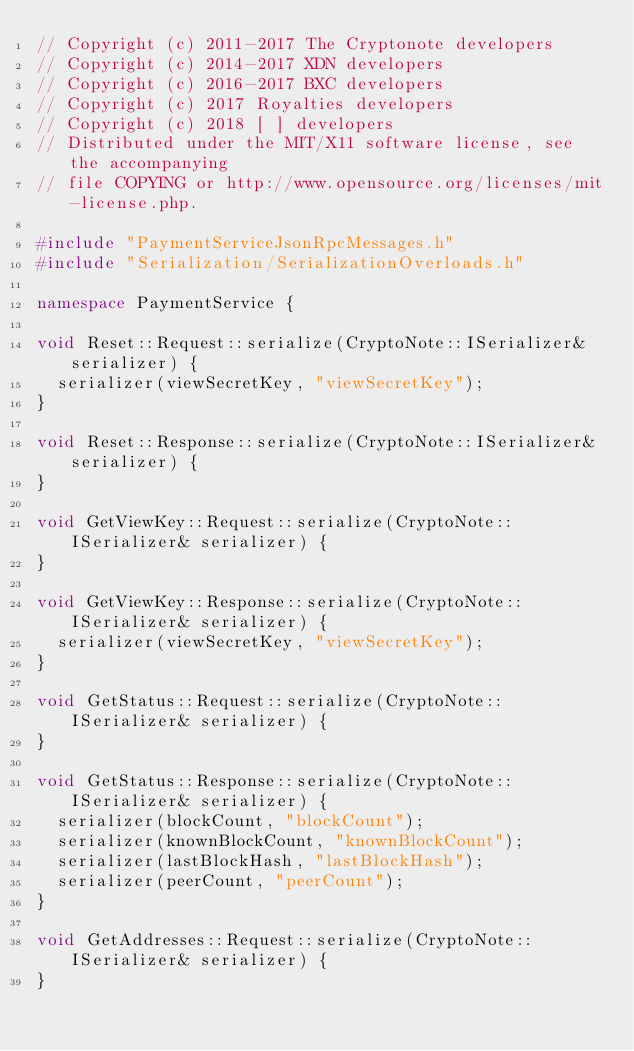<code> <loc_0><loc_0><loc_500><loc_500><_C++_>// Copyright (c) 2011-2017 The Cryptonote developers
// Copyright (c) 2014-2017 XDN developers
// Copyright (c) 2016-2017 BXC developers
// Copyright (c) 2017 Royalties developers
// Copyright (c) 2018 [ ] developers
// Distributed under the MIT/X11 software license, see the accompanying
// file COPYING or http://www.opensource.org/licenses/mit-license.php.

#include "PaymentServiceJsonRpcMessages.h"
#include "Serialization/SerializationOverloads.h"

namespace PaymentService {

void Reset::Request::serialize(CryptoNote::ISerializer& serializer) {
  serializer(viewSecretKey, "viewSecretKey");
}

void Reset::Response::serialize(CryptoNote::ISerializer& serializer) {
}

void GetViewKey::Request::serialize(CryptoNote::ISerializer& serializer) {
}

void GetViewKey::Response::serialize(CryptoNote::ISerializer& serializer) {
  serializer(viewSecretKey, "viewSecretKey");
}

void GetStatus::Request::serialize(CryptoNote::ISerializer& serializer) {
}

void GetStatus::Response::serialize(CryptoNote::ISerializer& serializer) {
  serializer(blockCount, "blockCount");
  serializer(knownBlockCount, "knownBlockCount");
  serializer(lastBlockHash, "lastBlockHash");
  serializer(peerCount, "peerCount");
}

void GetAddresses::Request::serialize(CryptoNote::ISerializer& serializer) {
}
</code> 